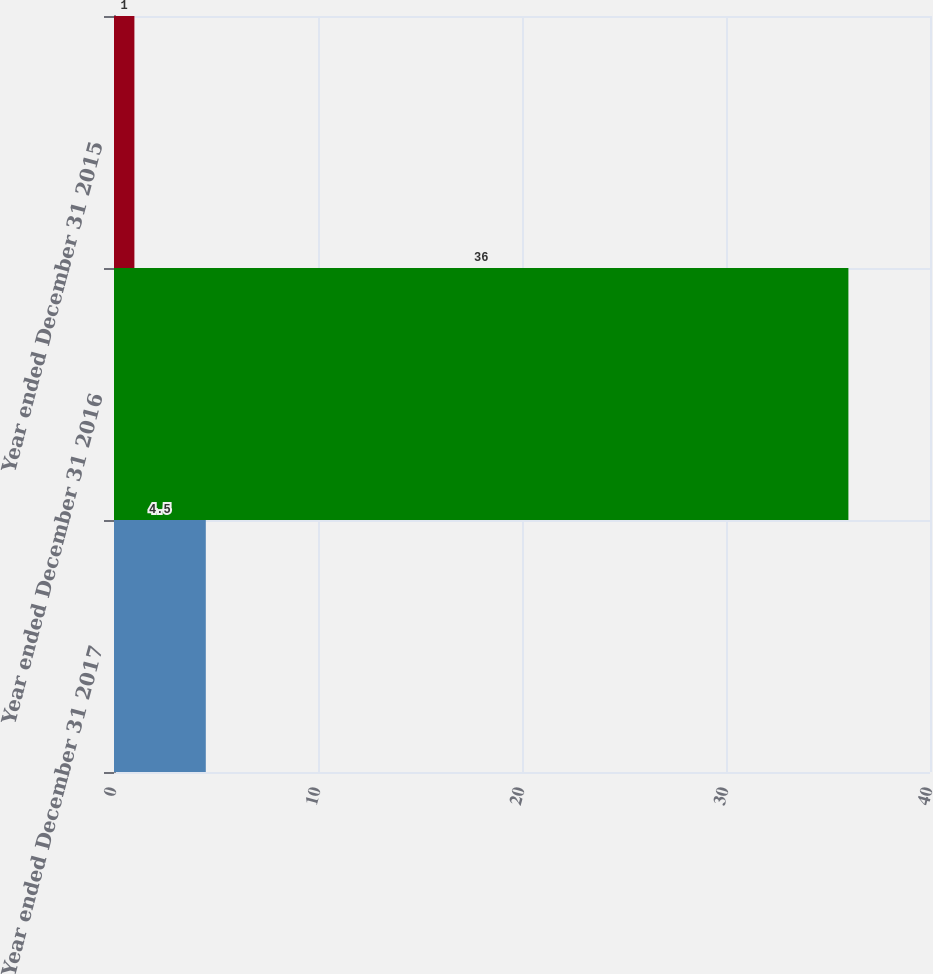Convert chart. <chart><loc_0><loc_0><loc_500><loc_500><bar_chart><fcel>Year ended December 31 2017<fcel>Year ended December 31 2016<fcel>Year ended December 31 2015<nl><fcel>4.5<fcel>36<fcel>1<nl></chart> 